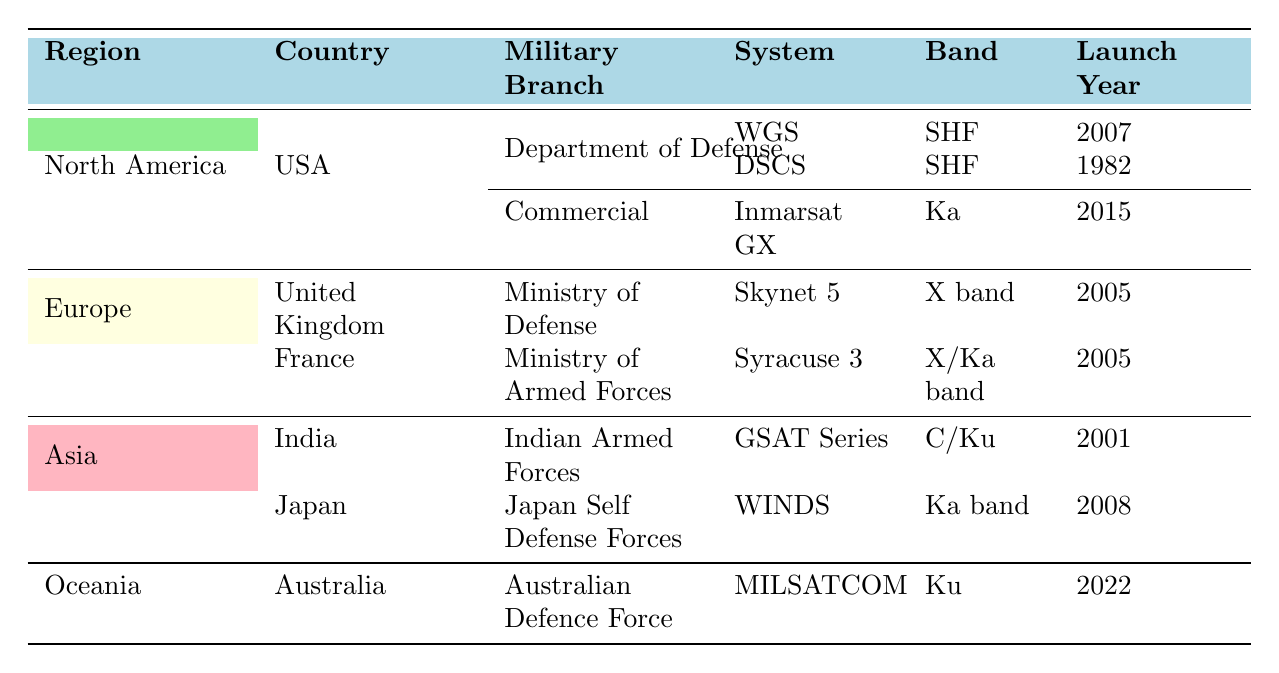What satellite communication systems are operated by the USA under the Department of Defense? The table lists two systems operated by the USA's Department of Defense: the Wideband Global SATCOM (WGS) and the Defense Satellite Communications System (DSCS).
Answer: WGS and DSCS Which country in Europe operates the Skynet 5 satellite communication system? According to the table, the United Kingdom operates the Skynet 5 satellite communication system under its Ministry of Defense.
Answer: United Kingdom Is there a satellite communication system in Oceania? The table shows that Australia has a satellite communication system called MILSATCOM operated by the Australian Defence Force. This indicates that yes, there is a system in Oceania.
Answer: Yes What frequency band is used by the Syracuse 3 satellite communication system? From the table, the Syracuse 3 system launches in 2005; its frequency band is listed as X/Ka band, which can be directly retrieved from the table.
Answer: X/Ka band How many military satellite communication systems are listed for Asia? The table presents two systems in Asia: GSAT Series (India) and WINDS (Japan). Therefore, adding these up, we find there are two military satellite systems in the Asia region.
Answer: 2 Which region has the latest launch year for a satellite communication system? To determine the latest launch year, we compare all launch years in the table: 2001 (GSAT Series), 2005 (Syracuse 3 and Skynet 5), 2007 (WGS), 2008 (WINDS), and 2022 (MILSATCOM). The MILSATCOM system in Oceania, launched in 2022, is the most recent.
Answer: Oceania Does India operate a satellite communication system? The data indicates that India operates the GSAT Series under its Indian Armed Forces, confirming that India does have a system.
Answer: Yes What is the average launch year of the satellite systems operated by North America? The systems for North America are WGS (2007), DSCS (1982), and Inmarsat GX (2015). To find the average: (2007 + 1982 + 2015) = 6004; then divide by 3 to get 2001.33. Therefore, rounding gives an average launch year of about 2001.
Answer: 2001 